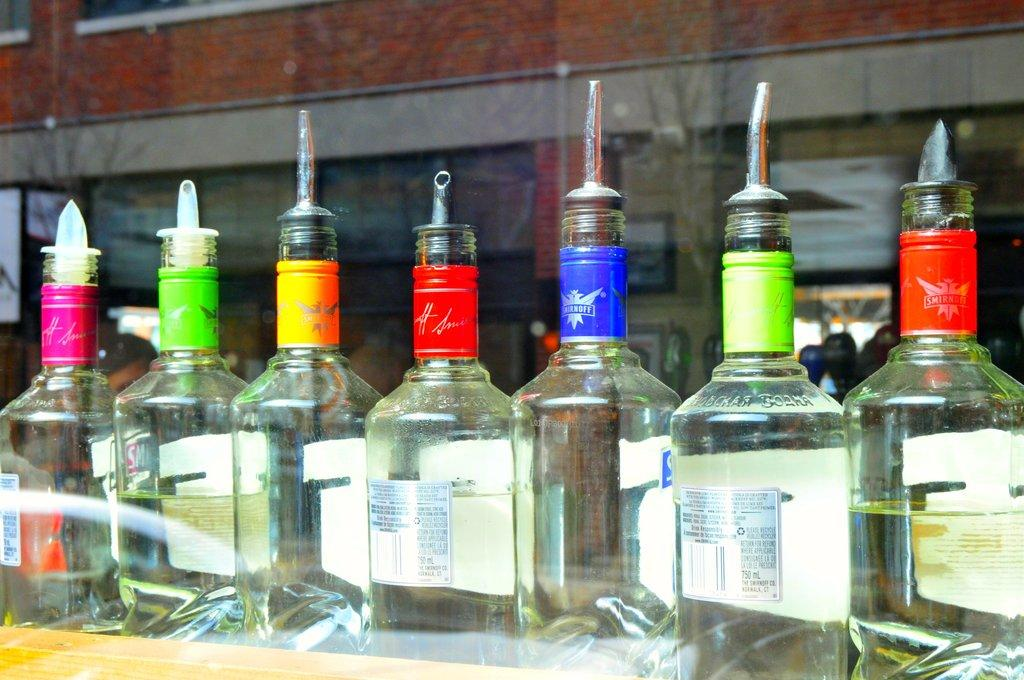How many bottles are visible in the image? There are seven bottles in the image. What type of pot is used to bake the cake in the image? There is no pot or cake present in the image; it only features seven bottles. What is the temperature of the hot item in the image? There is no hot item present in the image. 